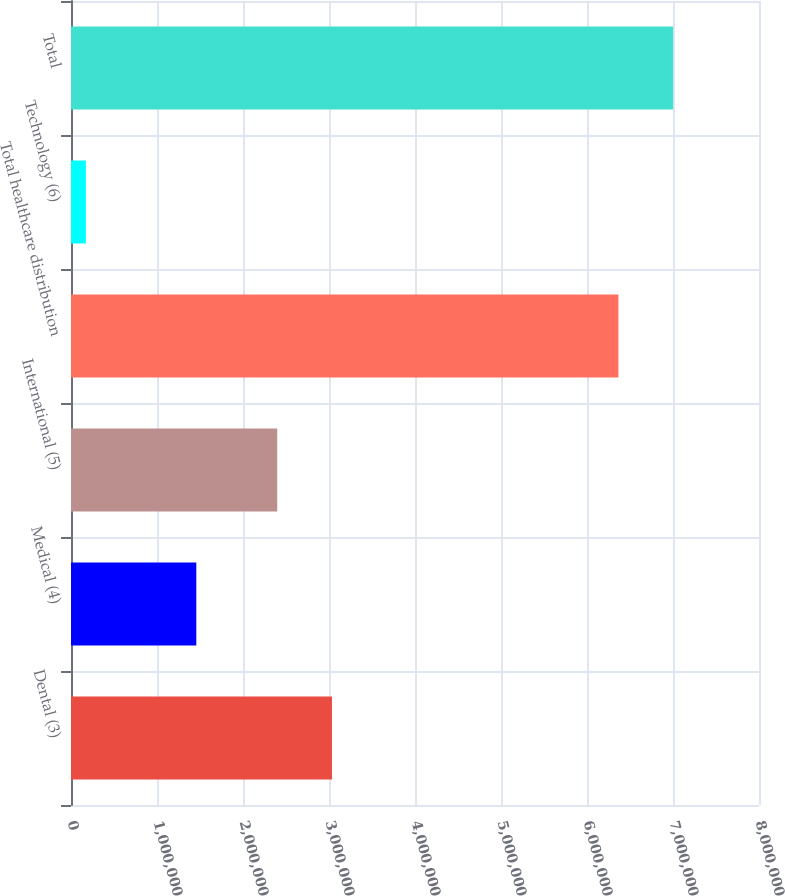<chart> <loc_0><loc_0><loc_500><loc_500><bar_chart><fcel>Dental (3)<fcel>Medical (4)<fcel>International (5)<fcel>Total healthcare distribution<fcel>Technology (6)<fcel>Total<nl><fcel>3.03462e+06<fcel>1.4571e+06<fcel>2.3981e+06<fcel>6.36513e+06<fcel>173208<fcel>7.00164e+06<nl></chart> 